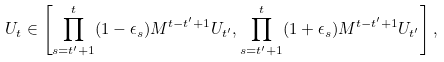Convert formula to latex. <formula><loc_0><loc_0><loc_500><loc_500>U _ { t } \in \left [ \prod _ { s = t ^ { \prime } + 1 } ^ { t } ( 1 - \epsilon _ { s } ) M ^ { t - t ^ { \prime } + 1 } U _ { t ^ { \prime } } , \prod _ { s = t ^ { \prime } + 1 } ^ { t } ( 1 + \epsilon _ { s } ) M ^ { t - t ^ { \prime } + 1 } U _ { t ^ { \prime } } \right ] ,</formula> 